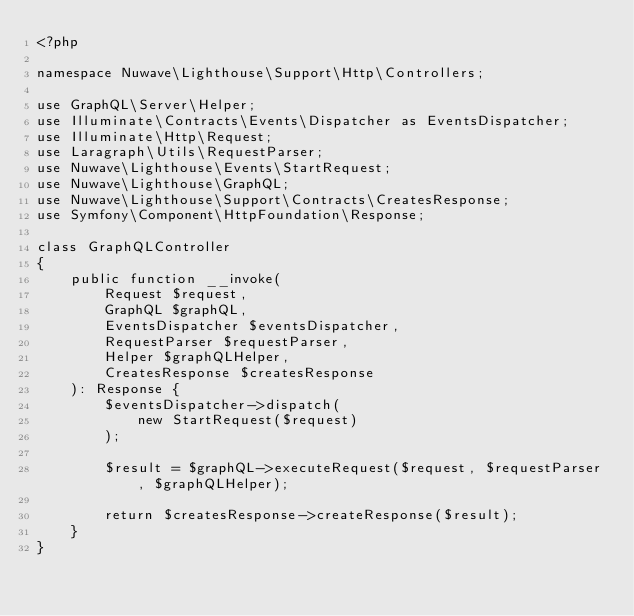Convert code to text. <code><loc_0><loc_0><loc_500><loc_500><_PHP_><?php

namespace Nuwave\Lighthouse\Support\Http\Controllers;

use GraphQL\Server\Helper;
use Illuminate\Contracts\Events\Dispatcher as EventsDispatcher;
use Illuminate\Http\Request;
use Laragraph\Utils\RequestParser;
use Nuwave\Lighthouse\Events\StartRequest;
use Nuwave\Lighthouse\GraphQL;
use Nuwave\Lighthouse\Support\Contracts\CreatesResponse;
use Symfony\Component\HttpFoundation\Response;

class GraphQLController
{
    public function __invoke(
        Request $request,
        GraphQL $graphQL,
        EventsDispatcher $eventsDispatcher,
        RequestParser $requestParser,
        Helper $graphQLHelper,
        CreatesResponse $createsResponse
    ): Response {
        $eventsDispatcher->dispatch(
            new StartRequest($request)
        );

        $result = $graphQL->executeRequest($request, $requestParser, $graphQLHelper);

        return $createsResponse->createResponse($result);
    }
}
</code> 